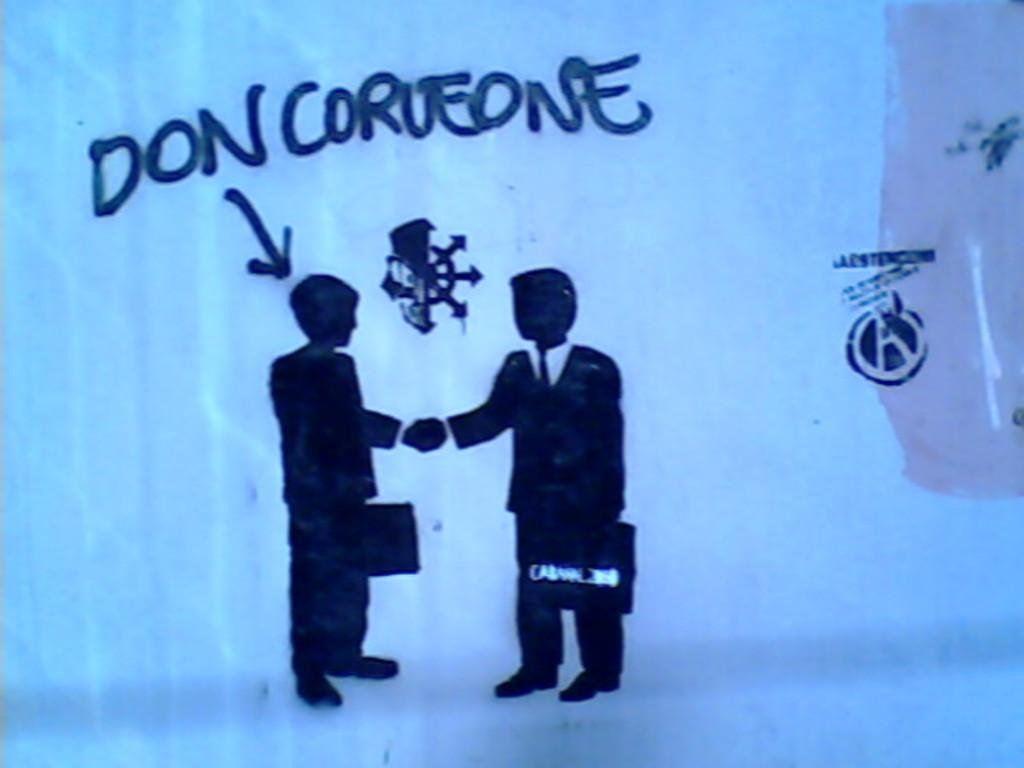<image>
Provide a brief description of the given image. the name Don that is on the surface with figures 